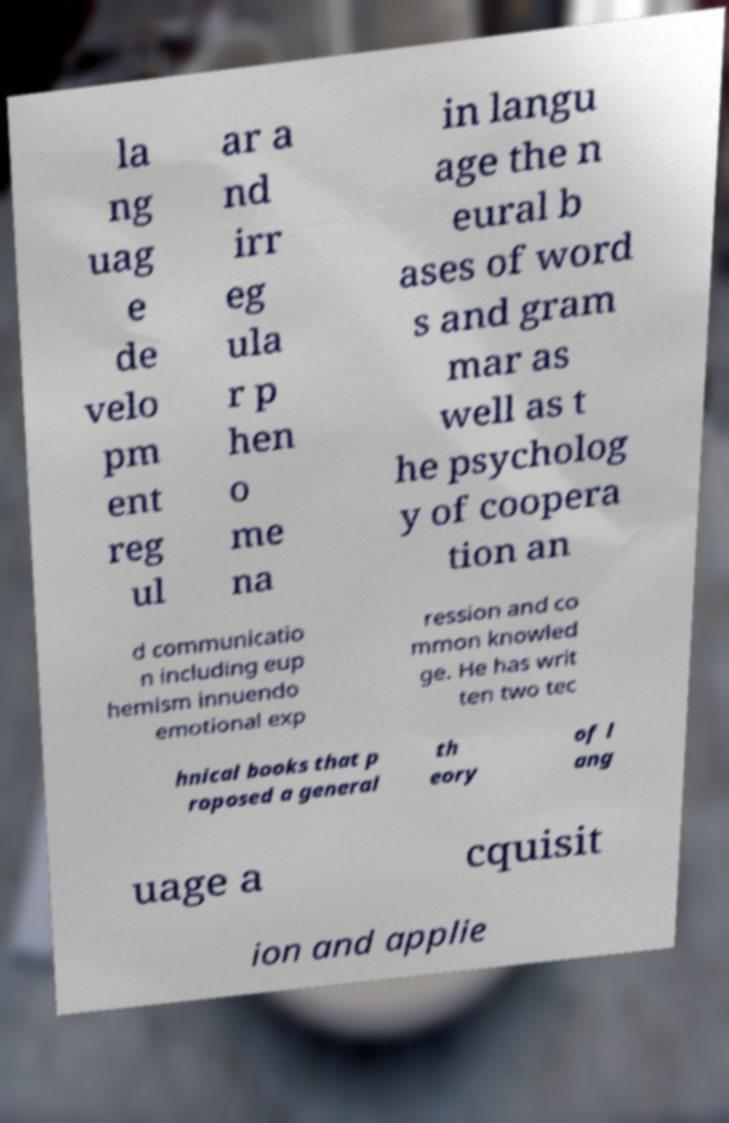What messages or text are displayed in this image? I need them in a readable, typed format. la ng uag e de velo pm ent reg ul ar a nd irr eg ula r p hen o me na in langu age the n eural b ases of word s and gram mar as well as t he psycholog y of coopera tion an d communicatio n including eup hemism innuendo emotional exp ression and co mmon knowled ge. He has writ ten two tec hnical books that p roposed a general th eory of l ang uage a cquisit ion and applie 